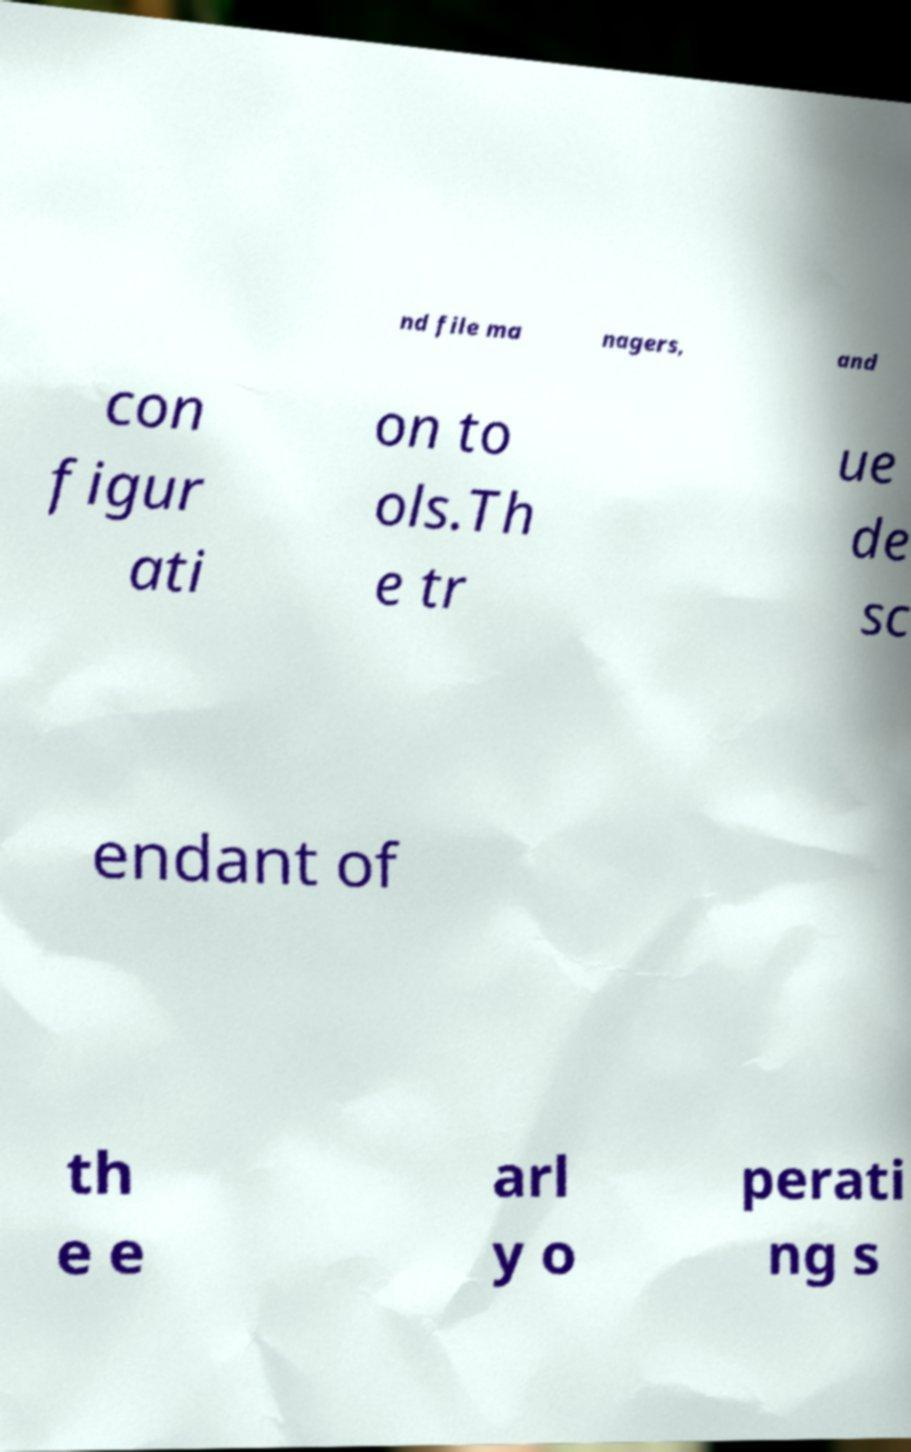For documentation purposes, I need the text within this image transcribed. Could you provide that? nd file ma nagers, and con figur ati on to ols.Th e tr ue de sc endant of th e e arl y o perati ng s 